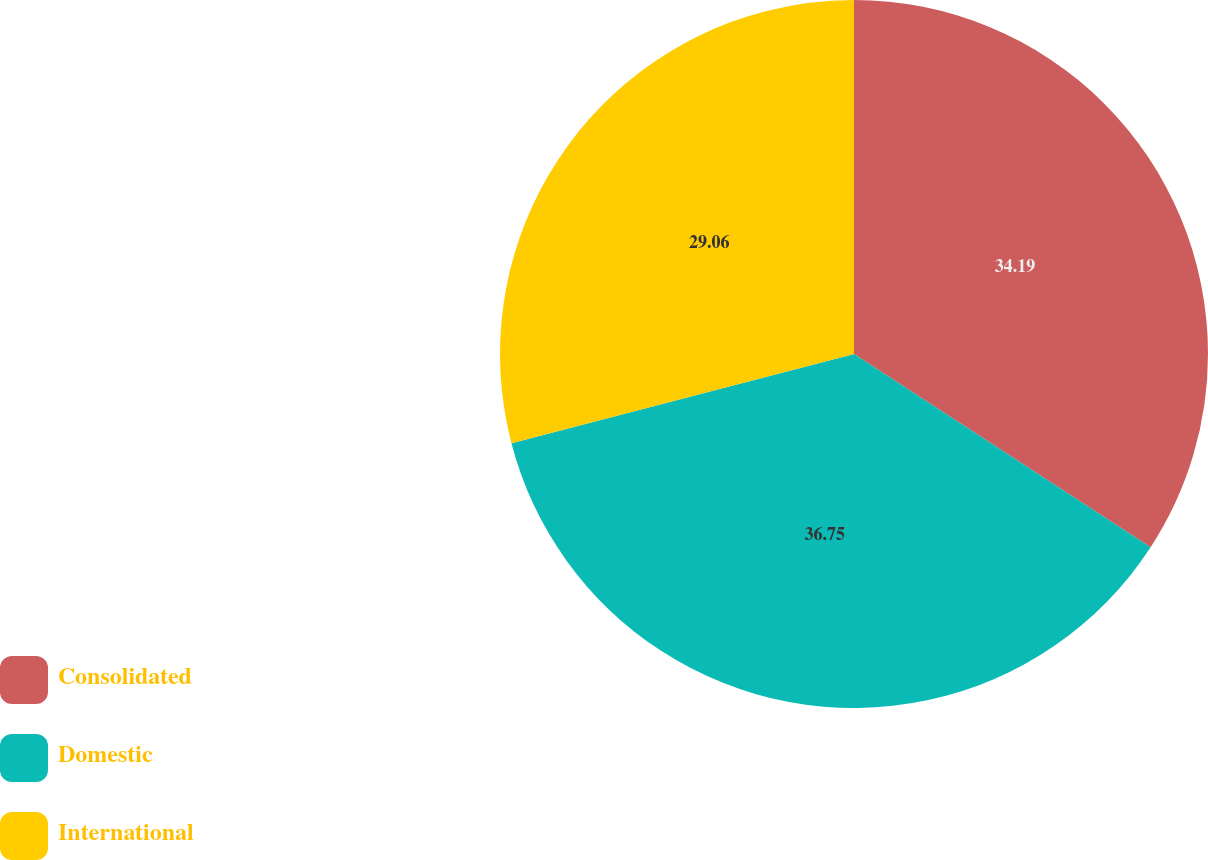Convert chart. <chart><loc_0><loc_0><loc_500><loc_500><pie_chart><fcel>Consolidated<fcel>Domestic<fcel>International<nl><fcel>34.19%<fcel>36.75%<fcel>29.06%<nl></chart> 